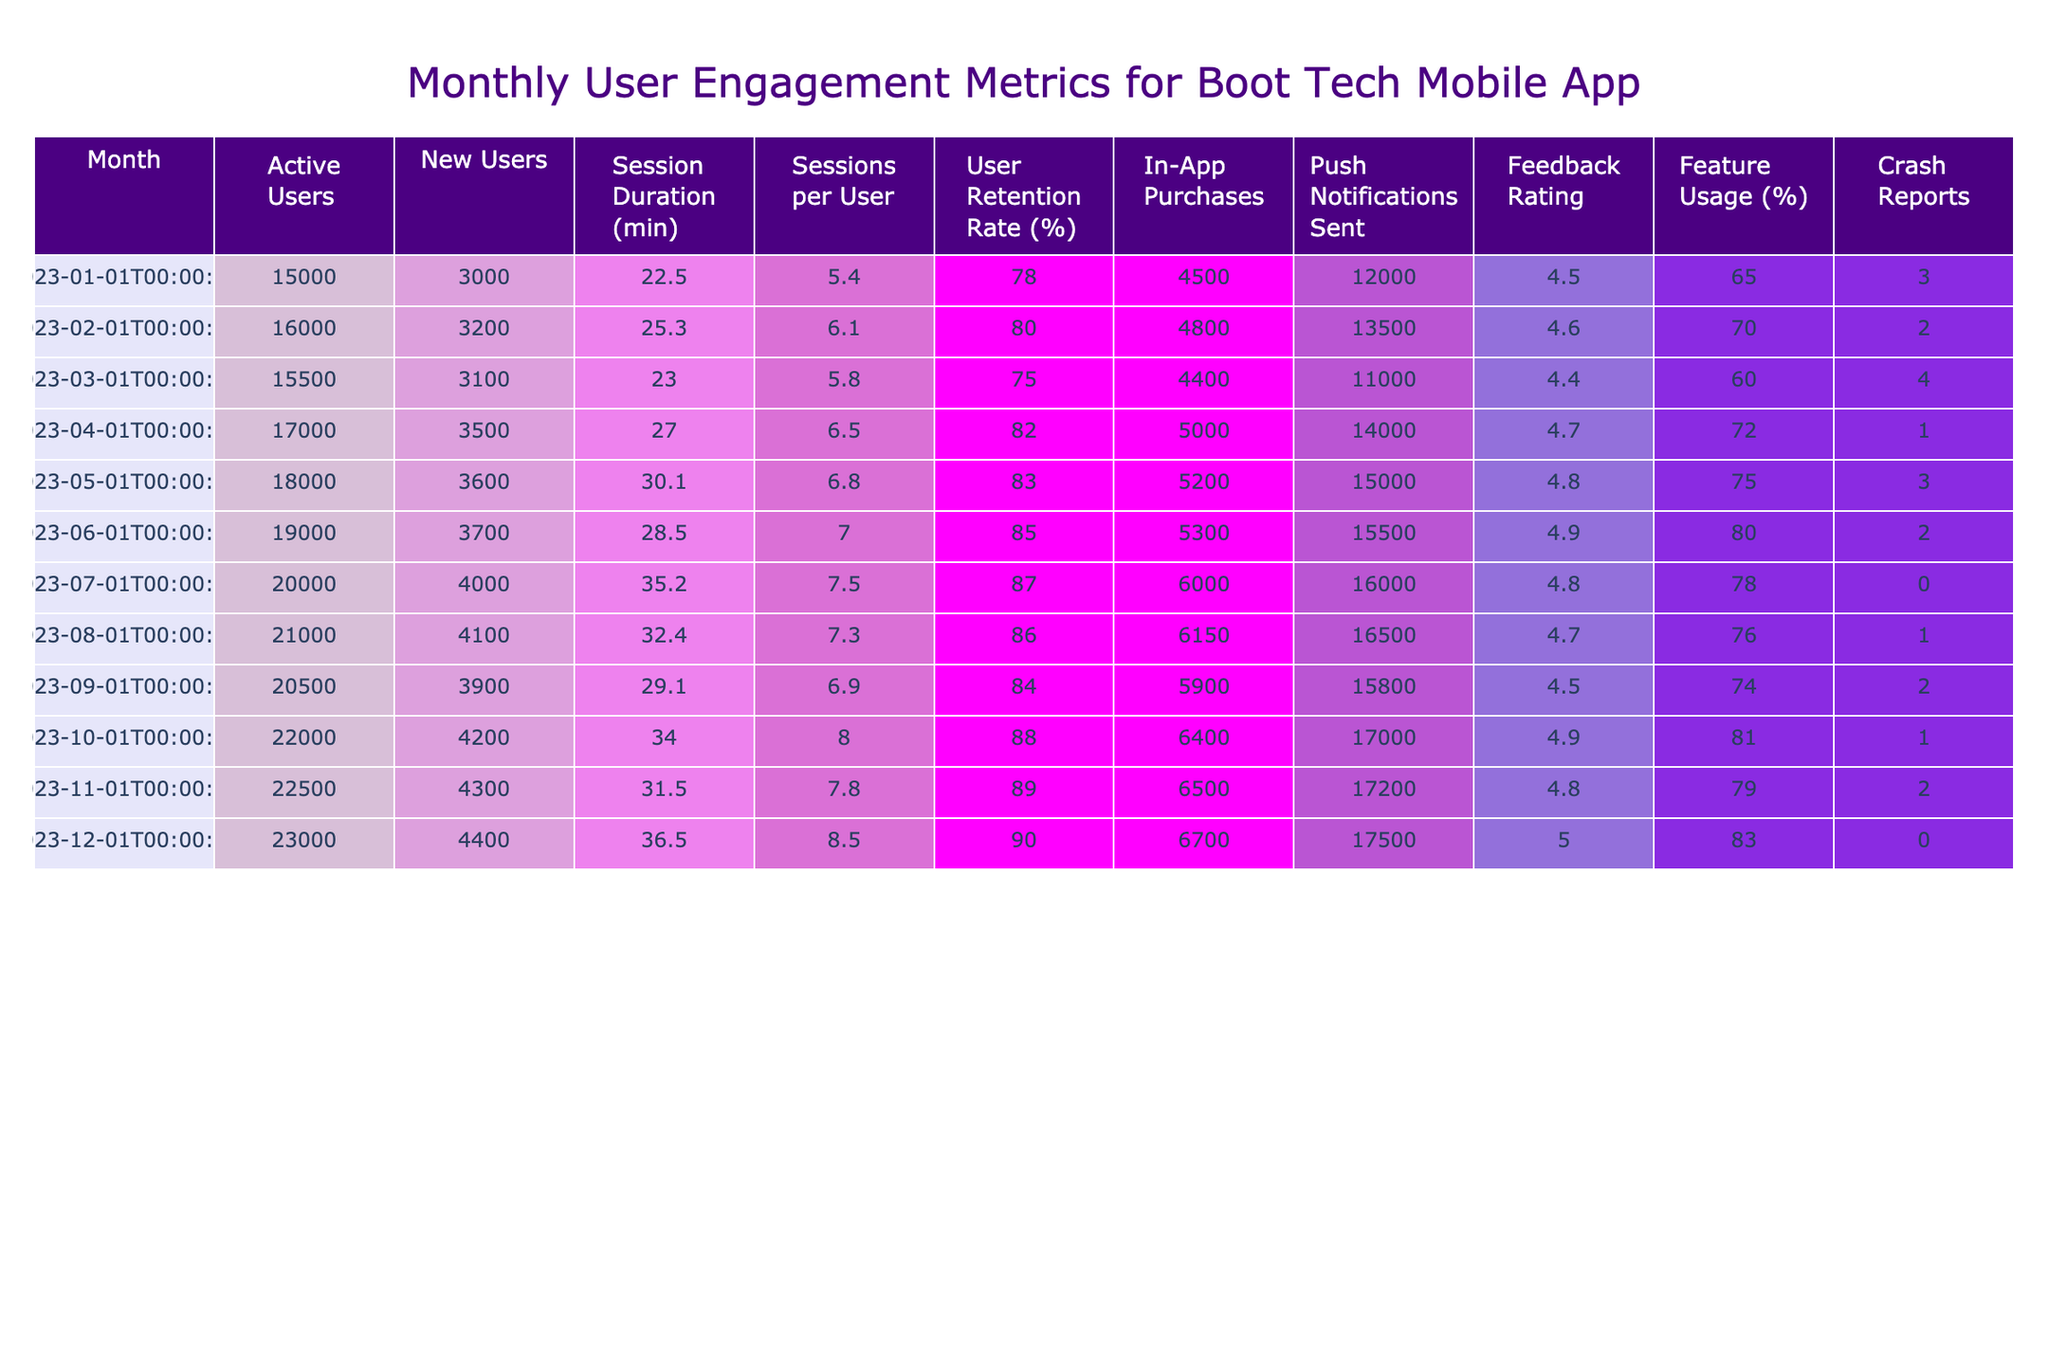What is the total number of Active Users in December 2023? The table shows that the Active Users in December 2023 is listed directly in the respective row for that month. It is 23000.
Answer: 23000 What was the User Retention Rate in April 2023? The User Retention Rate for April 2023 can be found in the row for that month in the table, which indicates it is 82%.
Answer: 82% What is the maximum Session Duration recorded in the table? By scanning the Session Duration column, the maximum value listed is 36.5 minutes in December 2023.
Answer: 36.5 How many New Users were added in the month of July 2023 compared to January 2023? The New Users in July 2023 is 4000 and in January 2023 is 3000. The difference is calculated as 4000 - 3000 = 1000.
Answer: 1000 What is the average Feedback Rating for the months between January and September 2023? Calculating the average involves adding the Feedback Ratings from those months: (4.5 + 4.6 + 4.4 + 4.7 + 4.8 + 4.9 + 4.8 + 4.7 + 4.5) = 40.4; then, divide by the number of months, which is 9. Therefore, the average is 40.4 / 9 ≈ 4.49.
Answer: 4.49 Did the number of Sessions per User increase from March to June? The Sessions per User in March 2023 was 5.8 and in June 2023 was 7.0. Since 7.0 is greater than 5.8, the statement is true that there was an increase.
Answer: Yes Which month had the highest number of In-App Purchases? Looking at the In-App Purchases column, December 2023 has the highest value listed at 6700.
Answer: 6700 What was the total number of Push Notifications Sent from January to August 2023? The total can be computed by summing the values in the Push Notifications Sent column for those months: 12000 + 13500 + 11000 + 14000 + 15000 + 15500 + 16000 + 16500 = 109500.
Answer: 109500 What was the trend in Feature Usage percentage from January to December 2023? By analyzing the Feature Usage percentages from each month, we see an increase from 65% in January to 83% in December, indicating a positive trend over the year.
Answer: Increase Was there any month in 2023 with crash reports higher than 3? Reviewing the Crash Reports column shows March with 4 and June with 2, indicating that there was one month, March 2023, that exceeded 3.
Answer: Yes What was the difference in Active Users between October and June 2023? The Active Users in October 2023 is 22000 and in June 2023 is 19000. The difference calculated is 22000 - 19000 = 3000.
Answer: 3000 